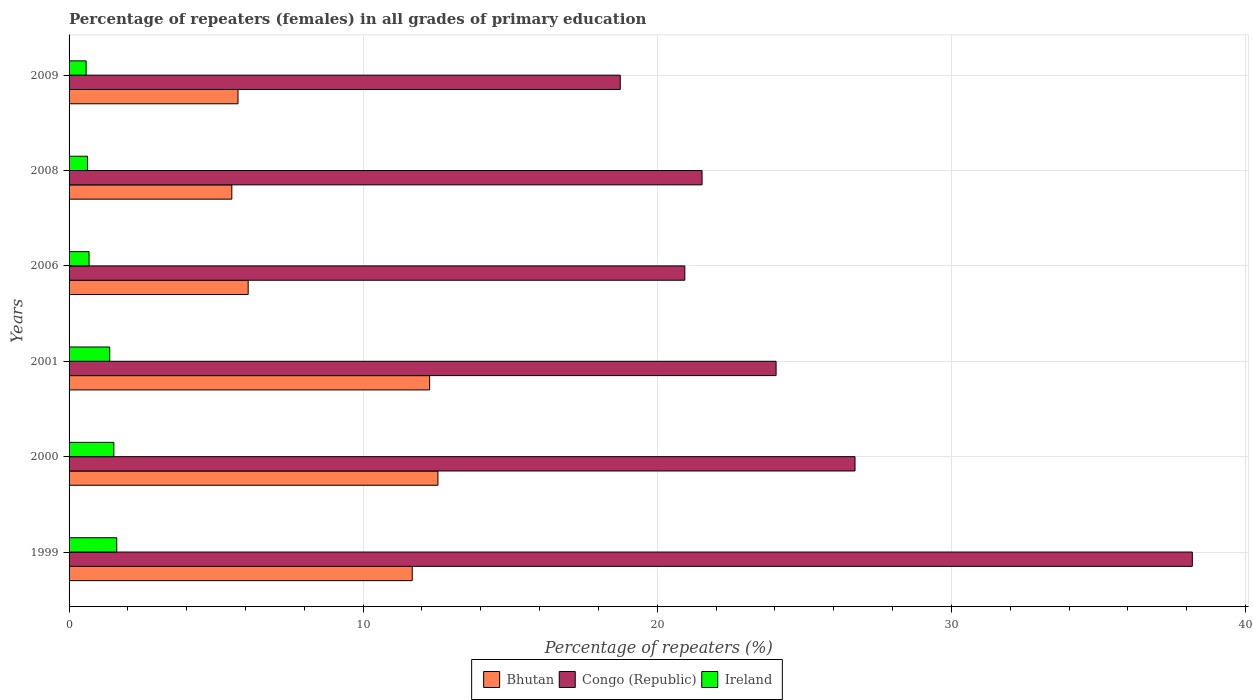Are the number of bars per tick equal to the number of legend labels?
Ensure brevity in your answer.  Yes. Are the number of bars on each tick of the Y-axis equal?
Make the answer very short. Yes. How many bars are there on the 5th tick from the bottom?
Provide a short and direct response. 3. In how many cases, is the number of bars for a given year not equal to the number of legend labels?
Give a very brief answer. 0. What is the percentage of repeaters (females) in Ireland in 1999?
Make the answer very short. 1.62. Across all years, what is the maximum percentage of repeaters (females) in Ireland?
Give a very brief answer. 1.62. Across all years, what is the minimum percentage of repeaters (females) in Bhutan?
Your answer should be very brief. 5.53. In which year was the percentage of repeaters (females) in Congo (Republic) minimum?
Keep it short and to the point. 2009. What is the total percentage of repeaters (females) in Congo (Republic) in the graph?
Make the answer very short. 150.16. What is the difference between the percentage of repeaters (females) in Ireland in 2000 and that in 2008?
Make the answer very short. 0.9. What is the difference between the percentage of repeaters (females) in Ireland in 2006 and the percentage of repeaters (females) in Bhutan in 2009?
Your answer should be compact. -5.06. What is the average percentage of repeaters (females) in Congo (Republic) per year?
Keep it short and to the point. 25.03. In the year 2000, what is the difference between the percentage of repeaters (females) in Ireland and percentage of repeaters (females) in Congo (Republic)?
Your response must be concise. -25.2. In how many years, is the percentage of repeaters (females) in Congo (Republic) greater than 10 %?
Your answer should be very brief. 6. What is the ratio of the percentage of repeaters (females) in Ireland in 1999 to that in 2009?
Offer a very short reply. 2.79. Is the difference between the percentage of repeaters (females) in Ireland in 1999 and 2000 greater than the difference between the percentage of repeaters (females) in Congo (Republic) in 1999 and 2000?
Your answer should be very brief. No. What is the difference between the highest and the second highest percentage of repeaters (females) in Ireland?
Keep it short and to the point. 0.1. What is the difference between the highest and the lowest percentage of repeaters (females) in Bhutan?
Provide a short and direct response. 7.01. In how many years, is the percentage of repeaters (females) in Congo (Republic) greater than the average percentage of repeaters (females) in Congo (Republic) taken over all years?
Provide a succinct answer. 2. Is the sum of the percentage of repeaters (females) in Congo (Republic) in 2000 and 2008 greater than the maximum percentage of repeaters (females) in Ireland across all years?
Offer a very short reply. Yes. What does the 3rd bar from the top in 2000 represents?
Offer a very short reply. Bhutan. What does the 3rd bar from the bottom in 2009 represents?
Your answer should be compact. Ireland. Is it the case that in every year, the sum of the percentage of repeaters (females) in Congo (Republic) and percentage of repeaters (females) in Bhutan is greater than the percentage of repeaters (females) in Ireland?
Make the answer very short. Yes. Are all the bars in the graph horizontal?
Provide a succinct answer. Yes. What is the difference between two consecutive major ticks on the X-axis?
Offer a terse response. 10. What is the title of the graph?
Provide a short and direct response. Percentage of repeaters (females) in all grades of primary education. What is the label or title of the X-axis?
Ensure brevity in your answer.  Percentage of repeaters (%). What is the label or title of the Y-axis?
Your answer should be compact. Years. What is the Percentage of repeaters (%) of Bhutan in 1999?
Your answer should be compact. 11.67. What is the Percentage of repeaters (%) in Congo (Republic) in 1999?
Your response must be concise. 38.19. What is the Percentage of repeaters (%) of Ireland in 1999?
Provide a succinct answer. 1.62. What is the Percentage of repeaters (%) in Bhutan in 2000?
Keep it short and to the point. 12.54. What is the Percentage of repeaters (%) of Congo (Republic) in 2000?
Make the answer very short. 26.72. What is the Percentage of repeaters (%) in Ireland in 2000?
Offer a very short reply. 1.52. What is the Percentage of repeaters (%) in Bhutan in 2001?
Your answer should be compact. 12.26. What is the Percentage of repeaters (%) in Congo (Republic) in 2001?
Keep it short and to the point. 24.04. What is the Percentage of repeaters (%) of Ireland in 2001?
Your answer should be compact. 1.38. What is the Percentage of repeaters (%) in Bhutan in 2006?
Your answer should be compact. 6.09. What is the Percentage of repeaters (%) in Congo (Republic) in 2006?
Provide a short and direct response. 20.94. What is the Percentage of repeaters (%) of Ireland in 2006?
Offer a terse response. 0.68. What is the Percentage of repeaters (%) of Bhutan in 2008?
Provide a succinct answer. 5.53. What is the Percentage of repeaters (%) in Congo (Republic) in 2008?
Your answer should be very brief. 21.52. What is the Percentage of repeaters (%) of Ireland in 2008?
Make the answer very short. 0.63. What is the Percentage of repeaters (%) of Bhutan in 2009?
Provide a succinct answer. 5.74. What is the Percentage of repeaters (%) of Congo (Republic) in 2009?
Provide a succinct answer. 18.74. What is the Percentage of repeaters (%) in Ireland in 2009?
Provide a succinct answer. 0.58. Across all years, what is the maximum Percentage of repeaters (%) in Bhutan?
Provide a short and direct response. 12.54. Across all years, what is the maximum Percentage of repeaters (%) of Congo (Republic)?
Offer a terse response. 38.19. Across all years, what is the maximum Percentage of repeaters (%) in Ireland?
Make the answer very short. 1.62. Across all years, what is the minimum Percentage of repeaters (%) of Bhutan?
Offer a very short reply. 5.53. Across all years, what is the minimum Percentage of repeaters (%) in Congo (Republic)?
Provide a succinct answer. 18.74. Across all years, what is the minimum Percentage of repeaters (%) of Ireland?
Your answer should be compact. 0.58. What is the total Percentage of repeaters (%) in Bhutan in the graph?
Provide a succinct answer. 53.84. What is the total Percentage of repeaters (%) in Congo (Republic) in the graph?
Provide a short and direct response. 150.16. What is the total Percentage of repeaters (%) in Ireland in the graph?
Your response must be concise. 6.41. What is the difference between the Percentage of repeaters (%) in Bhutan in 1999 and that in 2000?
Your answer should be very brief. -0.87. What is the difference between the Percentage of repeaters (%) of Congo (Republic) in 1999 and that in 2000?
Give a very brief answer. 11.47. What is the difference between the Percentage of repeaters (%) in Ireland in 1999 and that in 2000?
Keep it short and to the point. 0.1. What is the difference between the Percentage of repeaters (%) of Bhutan in 1999 and that in 2001?
Keep it short and to the point. -0.59. What is the difference between the Percentage of repeaters (%) of Congo (Republic) in 1999 and that in 2001?
Provide a short and direct response. 14.15. What is the difference between the Percentage of repeaters (%) in Ireland in 1999 and that in 2001?
Offer a terse response. 0.24. What is the difference between the Percentage of repeaters (%) of Bhutan in 1999 and that in 2006?
Ensure brevity in your answer.  5.58. What is the difference between the Percentage of repeaters (%) of Congo (Republic) in 1999 and that in 2006?
Provide a short and direct response. 17.26. What is the difference between the Percentage of repeaters (%) of Ireland in 1999 and that in 2006?
Offer a terse response. 0.94. What is the difference between the Percentage of repeaters (%) in Bhutan in 1999 and that in 2008?
Offer a very short reply. 6.13. What is the difference between the Percentage of repeaters (%) of Congo (Republic) in 1999 and that in 2008?
Offer a terse response. 16.67. What is the difference between the Percentage of repeaters (%) in Bhutan in 1999 and that in 2009?
Your answer should be compact. 5.92. What is the difference between the Percentage of repeaters (%) of Congo (Republic) in 1999 and that in 2009?
Give a very brief answer. 19.45. What is the difference between the Percentage of repeaters (%) in Ireland in 1999 and that in 2009?
Offer a very short reply. 1.04. What is the difference between the Percentage of repeaters (%) of Bhutan in 2000 and that in 2001?
Give a very brief answer. 0.28. What is the difference between the Percentage of repeaters (%) in Congo (Republic) in 2000 and that in 2001?
Your answer should be very brief. 2.68. What is the difference between the Percentage of repeaters (%) of Ireland in 2000 and that in 2001?
Offer a very short reply. 0.14. What is the difference between the Percentage of repeaters (%) in Bhutan in 2000 and that in 2006?
Provide a succinct answer. 6.45. What is the difference between the Percentage of repeaters (%) in Congo (Republic) in 2000 and that in 2006?
Offer a very short reply. 5.79. What is the difference between the Percentage of repeaters (%) in Ireland in 2000 and that in 2006?
Give a very brief answer. 0.84. What is the difference between the Percentage of repeaters (%) of Bhutan in 2000 and that in 2008?
Keep it short and to the point. 7.01. What is the difference between the Percentage of repeaters (%) of Congo (Republic) in 2000 and that in 2008?
Provide a short and direct response. 5.2. What is the difference between the Percentage of repeaters (%) of Ireland in 2000 and that in 2008?
Ensure brevity in your answer.  0.9. What is the difference between the Percentage of repeaters (%) in Bhutan in 2000 and that in 2009?
Your answer should be very brief. 6.8. What is the difference between the Percentage of repeaters (%) of Congo (Republic) in 2000 and that in 2009?
Your answer should be compact. 7.98. What is the difference between the Percentage of repeaters (%) in Ireland in 2000 and that in 2009?
Keep it short and to the point. 0.94. What is the difference between the Percentage of repeaters (%) of Bhutan in 2001 and that in 2006?
Your answer should be compact. 6.17. What is the difference between the Percentage of repeaters (%) in Congo (Republic) in 2001 and that in 2006?
Your response must be concise. 3.1. What is the difference between the Percentage of repeaters (%) of Ireland in 2001 and that in 2006?
Make the answer very short. 0.7. What is the difference between the Percentage of repeaters (%) in Bhutan in 2001 and that in 2008?
Offer a terse response. 6.73. What is the difference between the Percentage of repeaters (%) in Congo (Republic) in 2001 and that in 2008?
Your response must be concise. 2.52. What is the difference between the Percentage of repeaters (%) in Ireland in 2001 and that in 2008?
Your answer should be compact. 0.76. What is the difference between the Percentage of repeaters (%) in Bhutan in 2001 and that in 2009?
Provide a short and direct response. 6.51. What is the difference between the Percentage of repeaters (%) of Congo (Republic) in 2001 and that in 2009?
Keep it short and to the point. 5.3. What is the difference between the Percentage of repeaters (%) of Ireland in 2001 and that in 2009?
Keep it short and to the point. 0.8. What is the difference between the Percentage of repeaters (%) in Bhutan in 2006 and that in 2008?
Your answer should be very brief. 0.56. What is the difference between the Percentage of repeaters (%) of Congo (Republic) in 2006 and that in 2008?
Provide a succinct answer. -0.59. What is the difference between the Percentage of repeaters (%) in Ireland in 2006 and that in 2008?
Give a very brief answer. 0.05. What is the difference between the Percentage of repeaters (%) of Bhutan in 2006 and that in 2009?
Give a very brief answer. 0.35. What is the difference between the Percentage of repeaters (%) of Congo (Republic) in 2006 and that in 2009?
Ensure brevity in your answer.  2.2. What is the difference between the Percentage of repeaters (%) in Ireland in 2006 and that in 2009?
Keep it short and to the point. 0.1. What is the difference between the Percentage of repeaters (%) in Bhutan in 2008 and that in 2009?
Offer a terse response. -0.21. What is the difference between the Percentage of repeaters (%) in Congo (Republic) in 2008 and that in 2009?
Ensure brevity in your answer.  2.78. What is the difference between the Percentage of repeaters (%) of Ireland in 2008 and that in 2009?
Provide a succinct answer. 0.05. What is the difference between the Percentage of repeaters (%) of Bhutan in 1999 and the Percentage of repeaters (%) of Congo (Republic) in 2000?
Your response must be concise. -15.06. What is the difference between the Percentage of repeaters (%) of Bhutan in 1999 and the Percentage of repeaters (%) of Ireland in 2000?
Ensure brevity in your answer.  10.15. What is the difference between the Percentage of repeaters (%) in Congo (Republic) in 1999 and the Percentage of repeaters (%) in Ireland in 2000?
Your answer should be compact. 36.67. What is the difference between the Percentage of repeaters (%) of Bhutan in 1999 and the Percentage of repeaters (%) of Congo (Republic) in 2001?
Provide a succinct answer. -12.37. What is the difference between the Percentage of repeaters (%) in Bhutan in 1999 and the Percentage of repeaters (%) in Ireland in 2001?
Your answer should be compact. 10.29. What is the difference between the Percentage of repeaters (%) in Congo (Republic) in 1999 and the Percentage of repeaters (%) in Ireland in 2001?
Offer a very short reply. 36.81. What is the difference between the Percentage of repeaters (%) of Bhutan in 1999 and the Percentage of repeaters (%) of Congo (Republic) in 2006?
Your answer should be compact. -9.27. What is the difference between the Percentage of repeaters (%) in Bhutan in 1999 and the Percentage of repeaters (%) in Ireland in 2006?
Provide a succinct answer. 10.99. What is the difference between the Percentage of repeaters (%) in Congo (Republic) in 1999 and the Percentage of repeaters (%) in Ireland in 2006?
Ensure brevity in your answer.  37.51. What is the difference between the Percentage of repeaters (%) of Bhutan in 1999 and the Percentage of repeaters (%) of Congo (Republic) in 2008?
Provide a succinct answer. -9.85. What is the difference between the Percentage of repeaters (%) in Bhutan in 1999 and the Percentage of repeaters (%) in Ireland in 2008?
Make the answer very short. 11.04. What is the difference between the Percentage of repeaters (%) in Congo (Republic) in 1999 and the Percentage of repeaters (%) in Ireland in 2008?
Make the answer very short. 37.57. What is the difference between the Percentage of repeaters (%) in Bhutan in 1999 and the Percentage of repeaters (%) in Congo (Republic) in 2009?
Give a very brief answer. -7.07. What is the difference between the Percentage of repeaters (%) in Bhutan in 1999 and the Percentage of repeaters (%) in Ireland in 2009?
Provide a succinct answer. 11.09. What is the difference between the Percentage of repeaters (%) in Congo (Republic) in 1999 and the Percentage of repeaters (%) in Ireland in 2009?
Keep it short and to the point. 37.61. What is the difference between the Percentage of repeaters (%) of Bhutan in 2000 and the Percentage of repeaters (%) of Congo (Republic) in 2001?
Provide a short and direct response. -11.5. What is the difference between the Percentage of repeaters (%) in Bhutan in 2000 and the Percentage of repeaters (%) in Ireland in 2001?
Make the answer very short. 11.16. What is the difference between the Percentage of repeaters (%) in Congo (Republic) in 2000 and the Percentage of repeaters (%) in Ireland in 2001?
Your answer should be very brief. 25.34. What is the difference between the Percentage of repeaters (%) in Bhutan in 2000 and the Percentage of repeaters (%) in Congo (Republic) in 2006?
Give a very brief answer. -8.39. What is the difference between the Percentage of repeaters (%) of Bhutan in 2000 and the Percentage of repeaters (%) of Ireland in 2006?
Make the answer very short. 11.86. What is the difference between the Percentage of repeaters (%) of Congo (Republic) in 2000 and the Percentage of repeaters (%) of Ireland in 2006?
Make the answer very short. 26.04. What is the difference between the Percentage of repeaters (%) of Bhutan in 2000 and the Percentage of repeaters (%) of Congo (Republic) in 2008?
Keep it short and to the point. -8.98. What is the difference between the Percentage of repeaters (%) of Bhutan in 2000 and the Percentage of repeaters (%) of Ireland in 2008?
Provide a short and direct response. 11.92. What is the difference between the Percentage of repeaters (%) of Congo (Republic) in 2000 and the Percentage of repeaters (%) of Ireland in 2008?
Ensure brevity in your answer.  26.1. What is the difference between the Percentage of repeaters (%) of Bhutan in 2000 and the Percentage of repeaters (%) of Congo (Republic) in 2009?
Your answer should be very brief. -6.2. What is the difference between the Percentage of repeaters (%) in Bhutan in 2000 and the Percentage of repeaters (%) in Ireland in 2009?
Give a very brief answer. 11.96. What is the difference between the Percentage of repeaters (%) in Congo (Republic) in 2000 and the Percentage of repeaters (%) in Ireland in 2009?
Your answer should be very brief. 26.14. What is the difference between the Percentage of repeaters (%) in Bhutan in 2001 and the Percentage of repeaters (%) in Congo (Republic) in 2006?
Offer a very short reply. -8.68. What is the difference between the Percentage of repeaters (%) in Bhutan in 2001 and the Percentage of repeaters (%) in Ireland in 2006?
Offer a very short reply. 11.58. What is the difference between the Percentage of repeaters (%) of Congo (Republic) in 2001 and the Percentage of repeaters (%) of Ireland in 2006?
Keep it short and to the point. 23.36. What is the difference between the Percentage of repeaters (%) in Bhutan in 2001 and the Percentage of repeaters (%) in Congo (Republic) in 2008?
Provide a short and direct response. -9.26. What is the difference between the Percentage of repeaters (%) in Bhutan in 2001 and the Percentage of repeaters (%) in Ireland in 2008?
Give a very brief answer. 11.63. What is the difference between the Percentage of repeaters (%) in Congo (Republic) in 2001 and the Percentage of repeaters (%) in Ireland in 2008?
Give a very brief answer. 23.41. What is the difference between the Percentage of repeaters (%) in Bhutan in 2001 and the Percentage of repeaters (%) in Congo (Republic) in 2009?
Provide a short and direct response. -6.48. What is the difference between the Percentage of repeaters (%) of Bhutan in 2001 and the Percentage of repeaters (%) of Ireland in 2009?
Provide a short and direct response. 11.68. What is the difference between the Percentage of repeaters (%) in Congo (Republic) in 2001 and the Percentage of repeaters (%) in Ireland in 2009?
Ensure brevity in your answer.  23.46. What is the difference between the Percentage of repeaters (%) in Bhutan in 2006 and the Percentage of repeaters (%) in Congo (Republic) in 2008?
Keep it short and to the point. -15.43. What is the difference between the Percentage of repeaters (%) of Bhutan in 2006 and the Percentage of repeaters (%) of Ireland in 2008?
Offer a very short reply. 5.46. What is the difference between the Percentage of repeaters (%) of Congo (Republic) in 2006 and the Percentage of repeaters (%) of Ireland in 2008?
Provide a short and direct response. 20.31. What is the difference between the Percentage of repeaters (%) of Bhutan in 2006 and the Percentage of repeaters (%) of Congo (Republic) in 2009?
Your response must be concise. -12.65. What is the difference between the Percentage of repeaters (%) in Bhutan in 2006 and the Percentage of repeaters (%) in Ireland in 2009?
Your answer should be very brief. 5.51. What is the difference between the Percentage of repeaters (%) in Congo (Republic) in 2006 and the Percentage of repeaters (%) in Ireland in 2009?
Your answer should be very brief. 20.36. What is the difference between the Percentage of repeaters (%) of Bhutan in 2008 and the Percentage of repeaters (%) of Congo (Republic) in 2009?
Your response must be concise. -13.21. What is the difference between the Percentage of repeaters (%) in Bhutan in 2008 and the Percentage of repeaters (%) in Ireland in 2009?
Ensure brevity in your answer.  4.95. What is the difference between the Percentage of repeaters (%) of Congo (Republic) in 2008 and the Percentage of repeaters (%) of Ireland in 2009?
Offer a terse response. 20.94. What is the average Percentage of repeaters (%) of Bhutan per year?
Offer a very short reply. 8.97. What is the average Percentage of repeaters (%) of Congo (Republic) per year?
Offer a very short reply. 25.03. What is the average Percentage of repeaters (%) of Ireland per year?
Offer a terse response. 1.07. In the year 1999, what is the difference between the Percentage of repeaters (%) of Bhutan and Percentage of repeaters (%) of Congo (Republic)?
Your answer should be very brief. -26.52. In the year 1999, what is the difference between the Percentage of repeaters (%) in Bhutan and Percentage of repeaters (%) in Ireland?
Keep it short and to the point. 10.05. In the year 1999, what is the difference between the Percentage of repeaters (%) in Congo (Republic) and Percentage of repeaters (%) in Ireland?
Ensure brevity in your answer.  36.57. In the year 2000, what is the difference between the Percentage of repeaters (%) of Bhutan and Percentage of repeaters (%) of Congo (Republic)?
Your answer should be compact. -14.18. In the year 2000, what is the difference between the Percentage of repeaters (%) in Bhutan and Percentage of repeaters (%) in Ireland?
Provide a succinct answer. 11.02. In the year 2000, what is the difference between the Percentage of repeaters (%) in Congo (Republic) and Percentage of repeaters (%) in Ireland?
Your answer should be very brief. 25.2. In the year 2001, what is the difference between the Percentage of repeaters (%) in Bhutan and Percentage of repeaters (%) in Congo (Republic)?
Offer a very short reply. -11.78. In the year 2001, what is the difference between the Percentage of repeaters (%) in Bhutan and Percentage of repeaters (%) in Ireland?
Your answer should be compact. 10.88. In the year 2001, what is the difference between the Percentage of repeaters (%) of Congo (Republic) and Percentage of repeaters (%) of Ireland?
Your response must be concise. 22.66. In the year 2006, what is the difference between the Percentage of repeaters (%) of Bhutan and Percentage of repeaters (%) of Congo (Republic)?
Keep it short and to the point. -14.85. In the year 2006, what is the difference between the Percentage of repeaters (%) in Bhutan and Percentage of repeaters (%) in Ireland?
Your answer should be very brief. 5.41. In the year 2006, what is the difference between the Percentage of repeaters (%) of Congo (Republic) and Percentage of repeaters (%) of Ireland?
Keep it short and to the point. 20.26. In the year 2008, what is the difference between the Percentage of repeaters (%) of Bhutan and Percentage of repeaters (%) of Congo (Republic)?
Offer a very short reply. -15.99. In the year 2008, what is the difference between the Percentage of repeaters (%) of Bhutan and Percentage of repeaters (%) of Ireland?
Provide a short and direct response. 4.91. In the year 2008, what is the difference between the Percentage of repeaters (%) in Congo (Republic) and Percentage of repeaters (%) in Ireland?
Make the answer very short. 20.9. In the year 2009, what is the difference between the Percentage of repeaters (%) in Bhutan and Percentage of repeaters (%) in Congo (Republic)?
Offer a very short reply. -13. In the year 2009, what is the difference between the Percentage of repeaters (%) in Bhutan and Percentage of repeaters (%) in Ireland?
Ensure brevity in your answer.  5.16. In the year 2009, what is the difference between the Percentage of repeaters (%) in Congo (Republic) and Percentage of repeaters (%) in Ireland?
Your answer should be compact. 18.16. What is the ratio of the Percentage of repeaters (%) in Bhutan in 1999 to that in 2000?
Offer a very short reply. 0.93. What is the ratio of the Percentage of repeaters (%) in Congo (Republic) in 1999 to that in 2000?
Ensure brevity in your answer.  1.43. What is the ratio of the Percentage of repeaters (%) in Ireland in 1999 to that in 2000?
Give a very brief answer. 1.06. What is the ratio of the Percentage of repeaters (%) in Bhutan in 1999 to that in 2001?
Your answer should be very brief. 0.95. What is the ratio of the Percentage of repeaters (%) of Congo (Republic) in 1999 to that in 2001?
Your answer should be compact. 1.59. What is the ratio of the Percentage of repeaters (%) in Ireland in 1999 to that in 2001?
Provide a succinct answer. 1.17. What is the ratio of the Percentage of repeaters (%) of Bhutan in 1999 to that in 2006?
Ensure brevity in your answer.  1.92. What is the ratio of the Percentage of repeaters (%) of Congo (Republic) in 1999 to that in 2006?
Offer a terse response. 1.82. What is the ratio of the Percentage of repeaters (%) of Ireland in 1999 to that in 2006?
Your answer should be very brief. 2.38. What is the ratio of the Percentage of repeaters (%) of Bhutan in 1999 to that in 2008?
Your answer should be very brief. 2.11. What is the ratio of the Percentage of repeaters (%) of Congo (Republic) in 1999 to that in 2008?
Give a very brief answer. 1.77. What is the ratio of the Percentage of repeaters (%) in Ireland in 1999 to that in 2008?
Ensure brevity in your answer.  2.59. What is the ratio of the Percentage of repeaters (%) of Bhutan in 1999 to that in 2009?
Keep it short and to the point. 2.03. What is the ratio of the Percentage of repeaters (%) in Congo (Republic) in 1999 to that in 2009?
Make the answer very short. 2.04. What is the ratio of the Percentage of repeaters (%) in Ireland in 1999 to that in 2009?
Offer a terse response. 2.79. What is the ratio of the Percentage of repeaters (%) in Bhutan in 2000 to that in 2001?
Offer a very short reply. 1.02. What is the ratio of the Percentage of repeaters (%) in Congo (Republic) in 2000 to that in 2001?
Offer a very short reply. 1.11. What is the ratio of the Percentage of repeaters (%) in Ireland in 2000 to that in 2001?
Offer a very short reply. 1.1. What is the ratio of the Percentage of repeaters (%) in Bhutan in 2000 to that in 2006?
Offer a terse response. 2.06. What is the ratio of the Percentage of repeaters (%) in Congo (Republic) in 2000 to that in 2006?
Give a very brief answer. 1.28. What is the ratio of the Percentage of repeaters (%) in Ireland in 2000 to that in 2006?
Give a very brief answer. 2.24. What is the ratio of the Percentage of repeaters (%) in Bhutan in 2000 to that in 2008?
Offer a terse response. 2.27. What is the ratio of the Percentage of repeaters (%) in Congo (Republic) in 2000 to that in 2008?
Make the answer very short. 1.24. What is the ratio of the Percentage of repeaters (%) of Ireland in 2000 to that in 2008?
Your answer should be compact. 2.43. What is the ratio of the Percentage of repeaters (%) of Bhutan in 2000 to that in 2009?
Offer a terse response. 2.18. What is the ratio of the Percentage of repeaters (%) in Congo (Republic) in 2000 to that in 2009?
Ensure brevity in your answer.  1.43. What is the ratio of the Percentage of repeaters (%) in Ireland in 2000 to that in 2009?
Give a very brief answer. 2.62. What is the ratio of the Percentage of repeaters (%) of Bhutan in 2001 to that in 2006?
Keep it short and to the point. 2.01. What is the ratio of the Percentage of repeaters (%) of Congo (Republic) in 2001 to that in 2006?
Make the answer very short. 1.15. What is the ratio of the Percentage of repeaters (%) in Ireland in 2001 to that in 2006?
Keep it short and to the point. 2.03. What is the ratio of the Percentage of repeaters (%) in Bhutan in 2001 to that in 2008?
Give a very brief answer. 2.22. What is the ratio of the Percentage of repeaters (%) in Congo (Republic) in 2001 to that in 2008?
Offer a terse response. 1.12. What is the ratio of the Percentage of repeaters (%) of Ireland in 2001 to that in 2008?
Your answer should be compact. 2.21. What is the ratio of the Percentage of repeaters (%) in Bhutan in 2001 to that in 2009?
Ensure brevity in your answer.  2.13. What is the ratio of the Percentage of repeaters (%) of Congo (Republic) in 2001 to that in 2009?
Offer a very short reply. 1.28. What is the ratio of the Percentage of repeaters (%) of Ireland in 2001 to that in 2009?
Your response must be concise. 2.38. What is the ratio of the Percentage of repeaters (%) in Bhutan in 2006 to that in 2008?
Ensure brevity in your answer.  1.1. What is the ratio of the Percentage of repeaters (%) of Congo (Republic) in 2006 to that in 2008?
Provide a succinct answer. 0.97. What is the ratio of the Percentage of repeaters (%) of Ireland in 2006 to that in 2008?
Your answer should be very brief. 1.09. What is the ratio of the Percentage of repeaters (%) in Bhutan in 2006 to that in 2009?
Offer a terse response. 1.06. What is the ratio of the Percentage of repeaters (%) in Congo (Republic) in 2006 to that in 2009?
Ensure brevity in your answer.  1.12. What is the ratio of the Percentage of repeaters (%) of Ireland in 2006 to that in 2009?
Provide a succinct answer. 1.17. What is the ratio of the Percentage of repeaters (%) in Bhutan in 2008 to that in 2009?
Your answer should be very brief. 0.96. What is the ratio of the Percentage of repeaters (%) of Congo (Republic) in 2008 to that in 2009?
Make the answer very short. 1.15. What is the ratio of the Percentage of repeaters (%) of Ireland in 2008 to that in 2009?
Make the answer very short. 1.08. What is the difference between the highest and the second highest Percentage of repeaters (%) in Bhutan?
Your answer should be very brief. 0.28. What is the difference between the highest and the second highest Percentage of repeaters (%) of Congo (Republic)?
Provide a succinct answer. 11.47. What is the difference between the highest and the second highest Percentage of repeaters (%) of Ireland?
Provide a short and direct response. 0.1. What is the difference between the highest and the lowest Percentage of repeaters (%) in Bhutan?
Your answer should be very brief. 7.01. What is the difference between the highest and the lowest Percentage of repeaters (%) of Congo (Republic)?
Your answer should be compact. 19.45. What is the difference between the highest and the lowest Percentage of repeaters (%) in Ireland?
Provide a succinct answer. 1.04. 